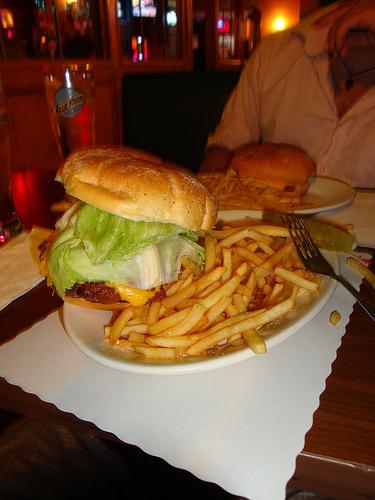What is the website in the corner of the picture?
Give a very brief answer. None. Does this picture represent a full meal?
Concise answer only. Yes. Is the American heart association likely to give this dish a thumbs up?
Short answer required. No. Is this a healthy lunch?
Concise answer only. No. What is the man holding over his mouth?
Keep it brief. Napkin. What color is the plate?
Keep it brief. White. Is this man eating lunch?
Short answer required. Yes. 